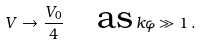Convert formula to latex. <formula><loc_0><loc_0><loc_500><loc_500>V \to \frac { V _ { 0 } } { 4 } \quad \text {as} \, k \varphi \gg 1 \, .</formula> 